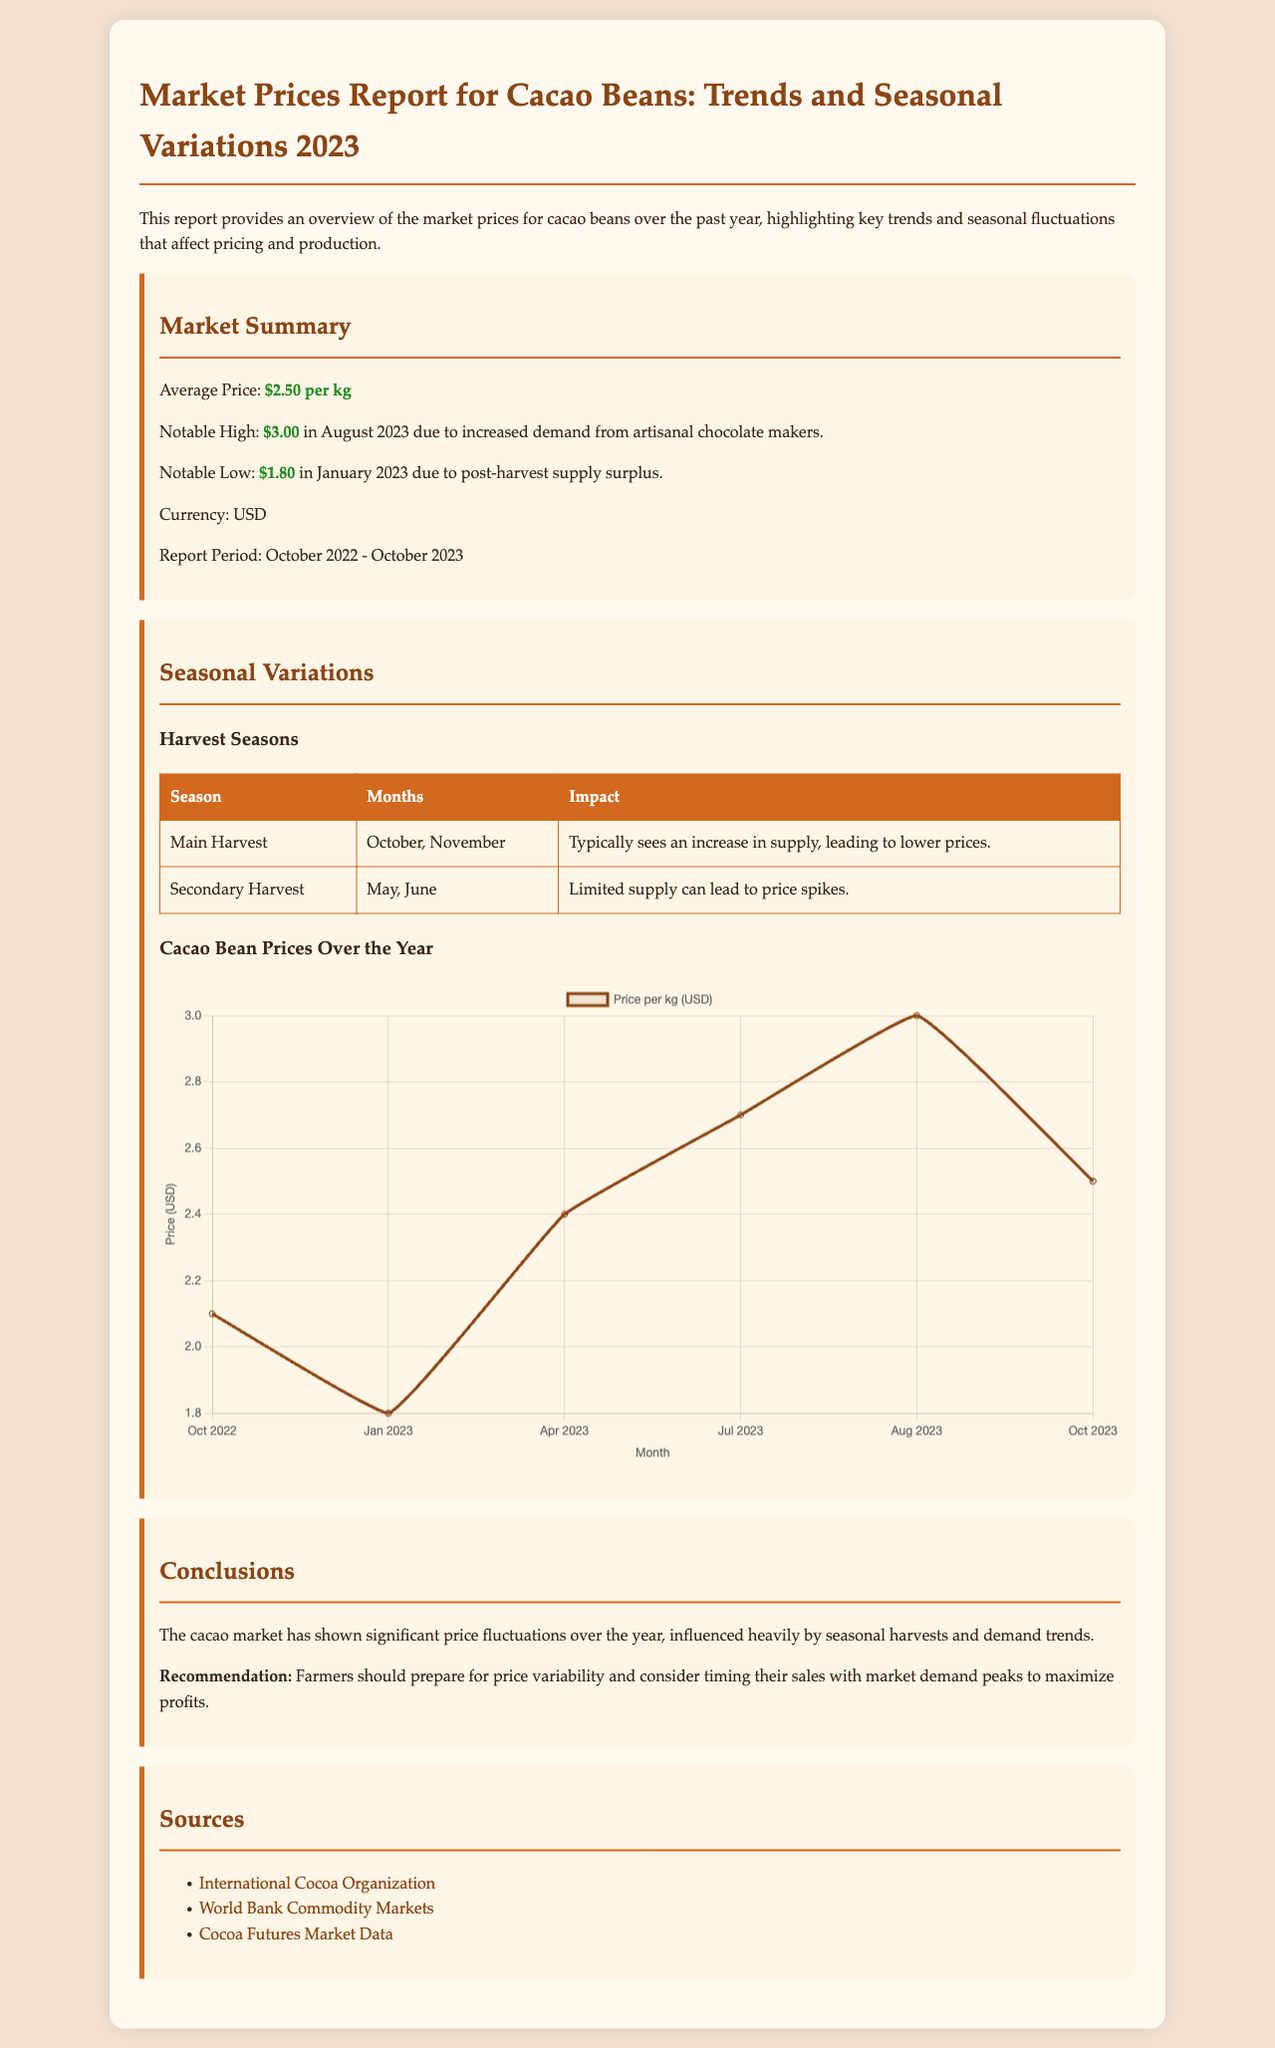what was the average price of cacao beans per kg? The average price mentioned in the report is the calculated mean of prices over the year, which is $2.50 per kg.
Answer: $2.50 per kg when did the notable high price occur? The notable high price is specified as occurring in August 2023, which was due to increased demand from artisanal chocolate makers.
Answer: August 2023 what was the notable low price recorded? The report outlines the lowest price recorded as $1.80 in January 2023 due to a post-harvest supply surplus.
Answer: $1.80 how many harvest seasons are described in the report? The report describes two specific harvest seasons and their respective impacts on cacao bean pricing.
Answer: Two what is the price trend from October 2022 to October 2023? The document demonstrates a fluctuation in prices throughout the year with general trends shown in a graph, reflecting a peak in August and a decline afterward.
Answer: Fluctuation what impact does the main harvest season have on prices? The report lists the impact of the main harvest as typically resulting in increased supply leading to lower prices.
Answer: Lower prices what was the highest price recorded for cacao beans? The highest price recorded in the report is $3.00, occurring in August 2023 due to demand increases.
Answer: $3.00 which organization is listed as a source in the report? The International Cocoa Organization is mentioned as one of the sources providing information relevant to the cacao market.
Answer: International Cocoa Organization 